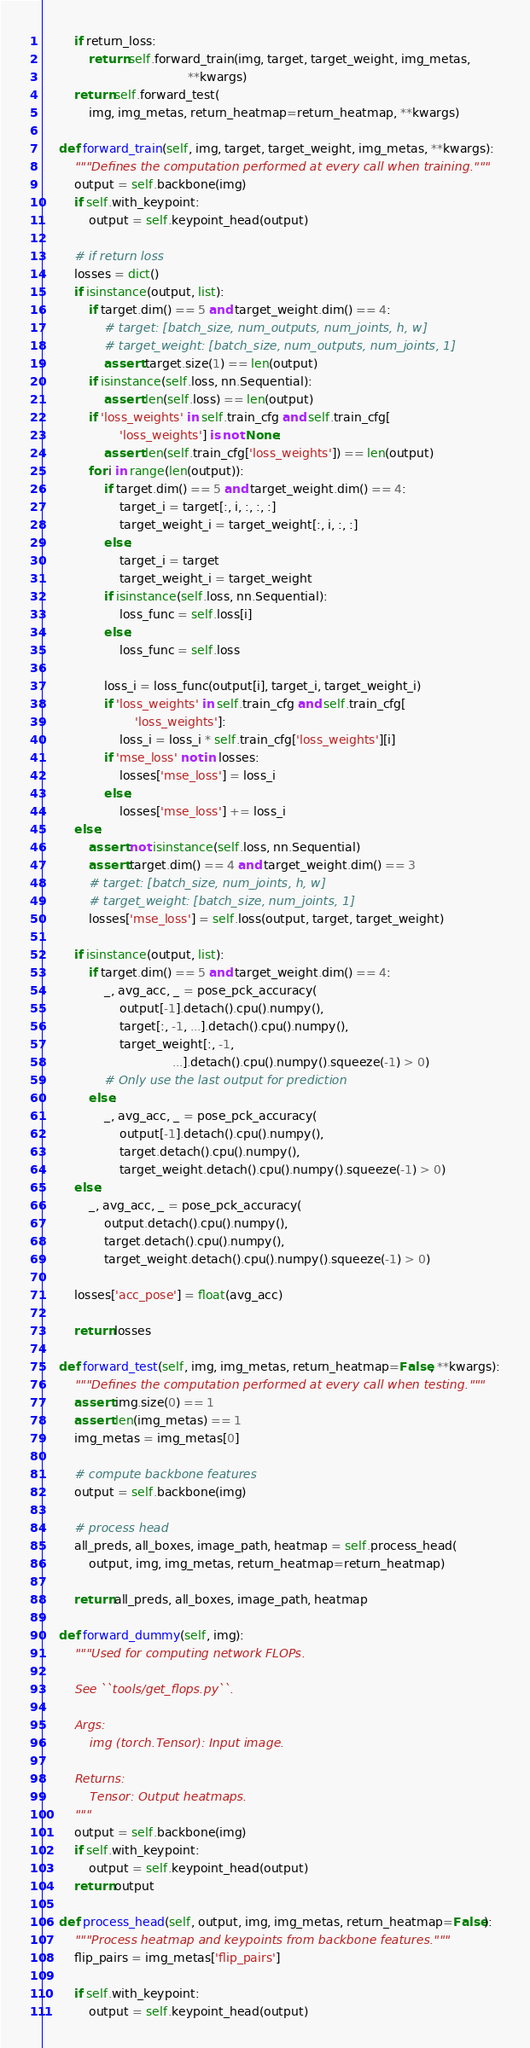<code> <loc_0><loc_0><loc_500><loc_500><_Python_>        if return_loss:
            return self.forward_train(img, target, target_weight, img_metas,
                                      **kwargs)
        return self.forward_test(
            img, img_metas, return_heatmap=return_heatmap, **kwargs)

    def forward_train(self, img, target, target_weight, img_metas, **kwargs):
        """Defines the computation performed at every call when training."""
        output = self.backbone(img)
        if self.with_keypoint:
            output = self.keypoint_head(output)

        # if return loss
        losses = dict()
        if isinstance(output, list):
            if target.dim() == 5 and target_weight.dim() == 4:
                # target: [batch_size, num_outputs, num_joints, h, w]
                # target_weight: [batch_size, num_outputs, num_joints, 1]
                assert target.size(1) == len(output)
            if isinstance(self.loss, nn.Sequential):
                assert len(self.loss) == len(output)
            if 'loss_weights' in self.train_cfg and self.train_cfg[
                    'loss_weights'] is not None:
                assert len(self.train_cfg['loss_weights']) == len(output)
            for i in range(len(output)):
                if target.dim() == 5 and target_weight.dim() == 4:
                    target_i = target[:, i, :, :, :]
                    target_weight_i = target_weight[:, i, :, :]
                else:
                    target_i = target
                    target_weight_i = target_weight
                if isinstance(self.loss, nn.Sequential):
                    loss_func = self.loss[i]
                else:
                    loss_func = self.loss

                loss_i = loss_func(output[i], target_i, target_weight_i)
                if 'loss_weights' in self.train_cfg and self.train_cfg[
                        'loss_weights']:
                    loss_i = loss_i * self.train_cfg['loss_weights'][i]
                if 'mse_loss' not in losses:
                    losses['mse_loss'] = loss_i
                else:
                    losses['mse_loss'] += loss_i
        else:
            assert not isinstance(self.loss, nn.Sequential)
            assert target.dim() == 4 and target_weight.dim() == 3
            # target: [batch_size, num_joints, h, w]
            # target_weight: [batch_size, num_joints, 1]
            losses['mse_loss'] = self.loss(output, target, target_weight)

        if isinstance(output, list):
            if target.dim() == 5 and target_weight.dim() == 4:
                _, avg_acc, _ = pose_pck_accuracy(
                    output[-1].detach().cpu().numpy(),
                    target[:, -1, ...].detach().cpu().numpy(),
                    target_weight[:, -1,
                                  ...].detach().cpu().numpy().squeeze(-1) > 0)
                # Only use the last output for prediction
            else:
                _, avg_acc, _ = pose_pck_accuracy(
                    output[-1].detach().cpu().numpy(),
                    target.detach().cpu().numpy(),
                    target_weight.detach().cpu().numpy().squeeze(-1) > 0)
        else:
            _, avg_acc, _ = pose_pck_accuracy(
                output.detach().cpu().numpy(),
                target.detach().cpu().numpy(),
                target_weight.detach().cpu().numpy().squeeze(-1) > 0)

        losses['acc_pose'] = float(avg_acc)

        return losses

    def forward_test(self, img, img_metas, return_heatmap=False, **kwargs):
        """Defines the computation performed at every call when testing."""
        assert img.size(0) == 1
        assert len(img_metas) == 1
        img_metas = img_metas[0]

        # compute backbone features
        output = self.backbone(img)

        # process head
        all_preds, all_boxes, image_path, heatmap = self.process_head(
            output, img, img_metas, return_heatmap=return_heatmap)

        return all_preds, all_boxes, image_path, heatmap

    def forward_dummy(self, img):
        """Used for computing network FLOPs.

        See ``tools/get_flops.py``.

        Args:
            img (torch.Tensor): Input image.

        Returns:
            Tensor: Output heatmaps.
        """
        output = self.backbone(img)
        if self.with_keypoint:
            output = self.keypoint_head(output)
        return output

    def process_head(self, output, img, img_metas, return_heatmap=False):
        """Process heatmap and keypoints from backbone features."""
        flip_pairs = img_metas['flip_pairs']

        if self.with_keypoint:
            output = self.keypoint_head(output)
</code> 